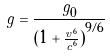<formula> <loc_0><loc_0><loc_500><loc_500>g = \frac { g _ { 0 } } { ( { 1 + \frac { v ^ { 6 } } { c ^ { 6 } } ) } ^ { 9 / 6 } }</formula> 